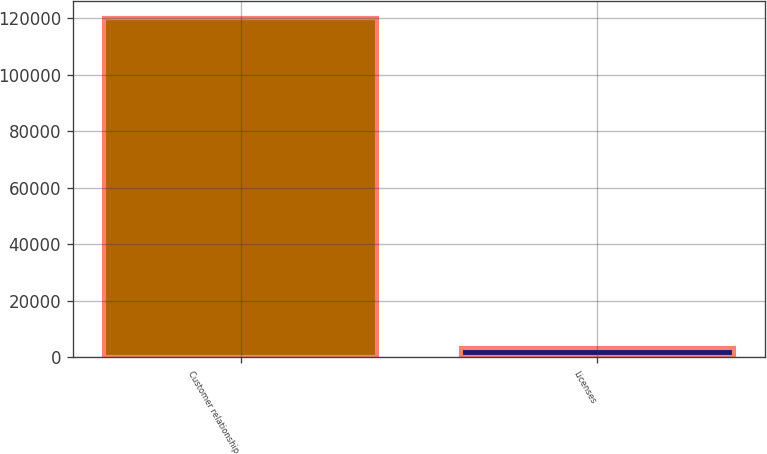<chart> <loc_0><loc_0><loc_500><loc_500><bar_chart><fcel>Customer relationship<fcel>Licenses<nl><fcel>120000<fcel>3368<nl></chart> 